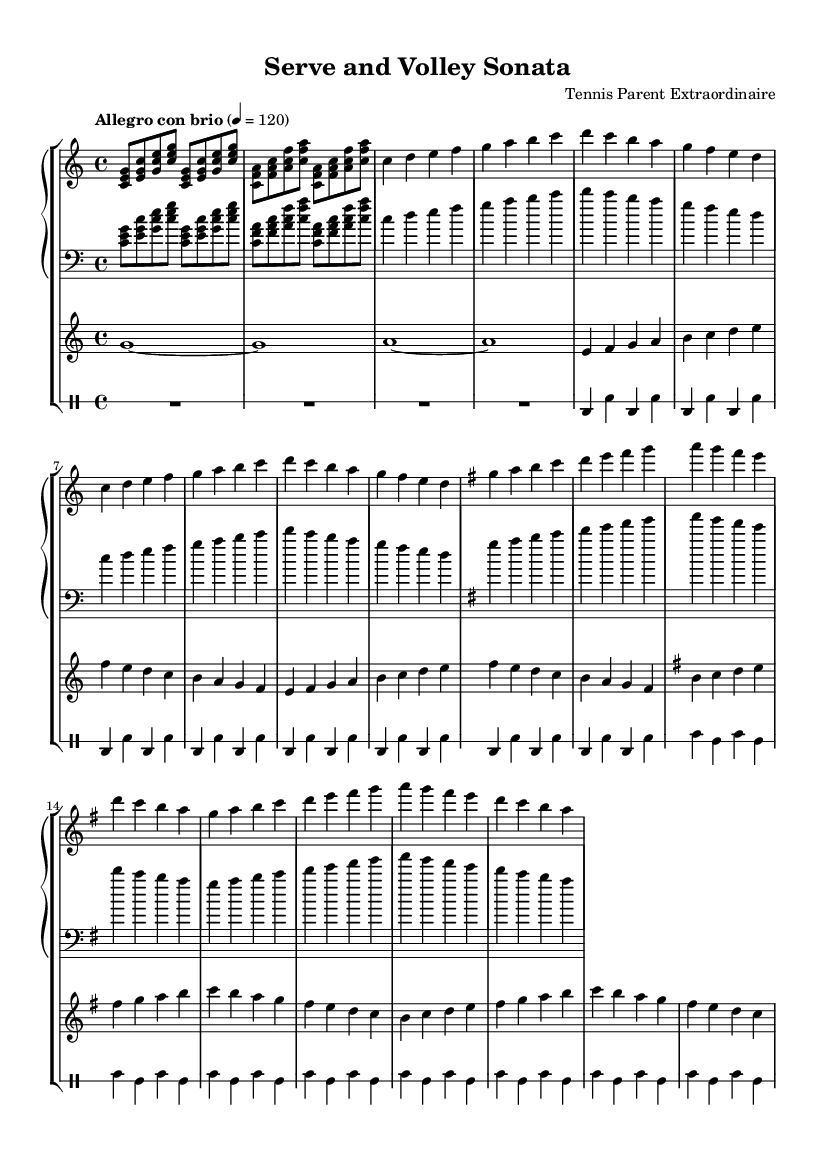What is the key signature of this music? The key signature changes between C major and G major. C major has no sharps or flats, while G major has one sharp (F#). The first part of the music is in C major, and the theme B section temporarily modulates to G major as indicated by the key signature change.
Answer: C major, G major What is the time signature of this music? The time signature is found at the beginning of the sheet music, indicated as 4/4. This means there are four beats per measure and the quarter note gets one beat. The consistent pattern throughout the piece supports this time signature.
Answer: 4/4 What is the tempo marking of this music? The tempo marking is indicated as "Allegro con brio" at the beginning. This suggests a fast, lively speed. The metronome marking of 120 beats per minute gives a specific speed reference for the performance.
Answer: Allegro con brio What type of instruments are used in this piece? The piece features three different instrument types: piano, violin, and drums. The piano plays both treble and bass sections, the violin plays a melodic line, and the drum staff provides rhythmic accompaniment.
Answer: Piano, Violin, Drums How many times is the introduction repeated? The introduction section of the music is repeated twice as indicated by the "repeat unfold 2" directive. This part establishes the thematic material and rhythm that recurs throughout the piece, setting the stage for the themes that follow.
Answer: 2 What rhythmic elements are used in the tennis section? The rhythmic elements in the tennis section include a combination of bass drum (bd) and snare drum (sn) patterns, creating a playful and dynamic rhythm inspired by the sounds of a tennis match. The toms (tommh, tomml) provide additional texture.
Answer: Bass drum and snare drum 